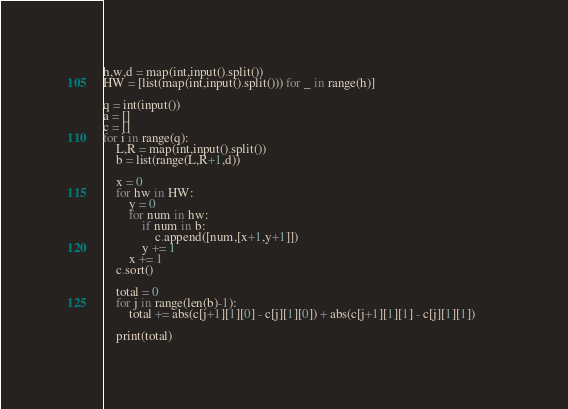Convert code to text. <code><loc_0><loc_0><loc_500><loc_500><_Python_>h,w,d = map(int,input().split())
HW = [list(map(int,input().split())) for _ in range(h)]

q = int(input())
a = []
c = []
for i in range(q):
    L,R = map(int,input().split())
    b = list(range(L,R+1,d))
    
    x = 0
    for hw in HW:
        y = 0
        for num in hw:
            if num in b:
                c.append([num,[x+1,y+1]])
            y += 1
        x += 1
    c.sort()
    
    total = 0
    for j in range(len(b)-1):
        total += abs(c[j+1][1][0] - c[j][1][0]) + abs(c[j+1][1][1] - c[j][1][1])        
        
    print(total)</code> 